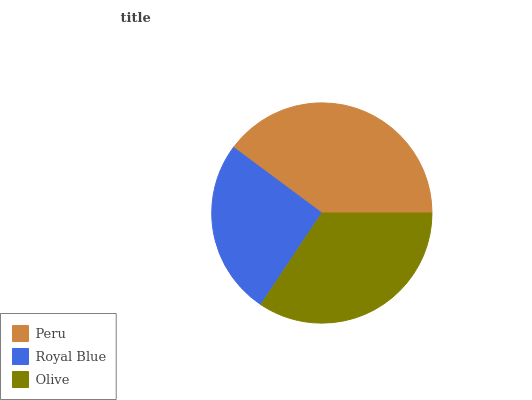Is Royal Blue the minimum?
Answer yes or no. Yes. Is Peru the maximum?
Answer yes or no. Yes. Is Olive the minimum?
Answer yes or no. No. Is Olive the maximum?
Answer yes or no. No. Is Olive greater than Royal Blue?
Answer yes or no. Yes. Is Royal Blue less than Olive?
Answer yes or no. Yes. Is Royal Blue greater than Olive?
Answer yes or no. No. Is Olive less than Royal Blue?
Answer yes or no. No. Is Olive the high median?
Answer yes or no. Yes. Is Olive the low median?
Answer yes or no. Yes. Is Royal Blue the high median?
Answer yes or no. No. Is Royal Blue the low median?
Answer yes or no. No. 